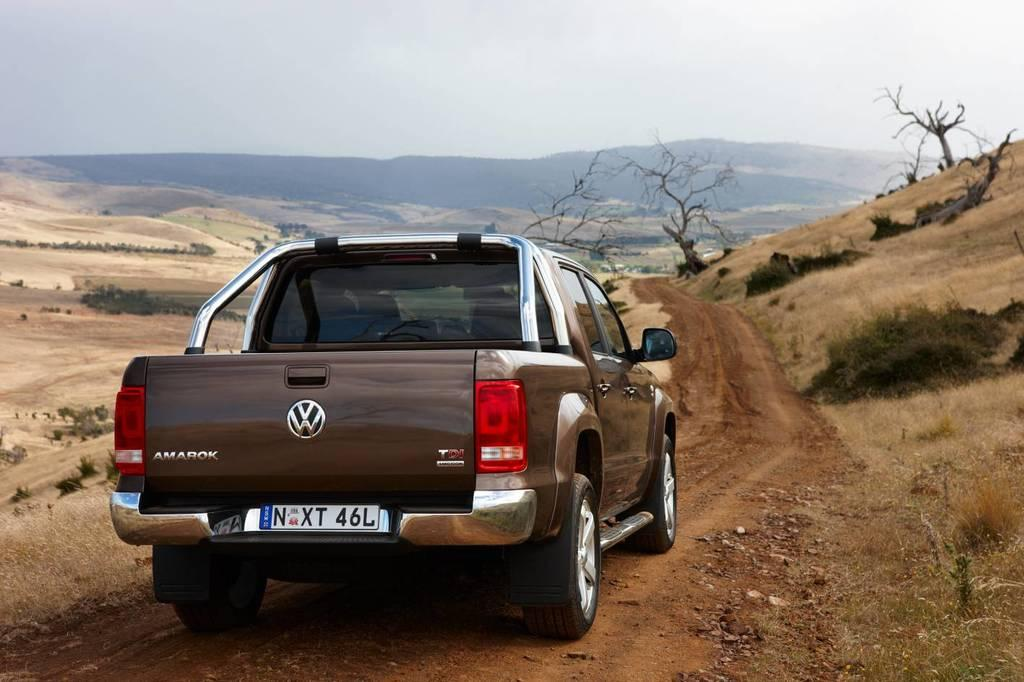What type of motor vehicle is in the image? The type of motor vehicle is not specified in the facts. Where is the motor vehicle located in the image? The motor vehicle is on the road in the image. What can be seen in the background of the image? In the background of the image, there are hills, trees, grass, bushes, and stones visible. How many different types of natural elements are present in the background of the image? There are five different types of natural elements present in the background of the image: hills, trees, grass, bushes, and stones. What substance is being used to fill the hole in the image? There is no hole present in the image, so no substance is being used to fill it. 